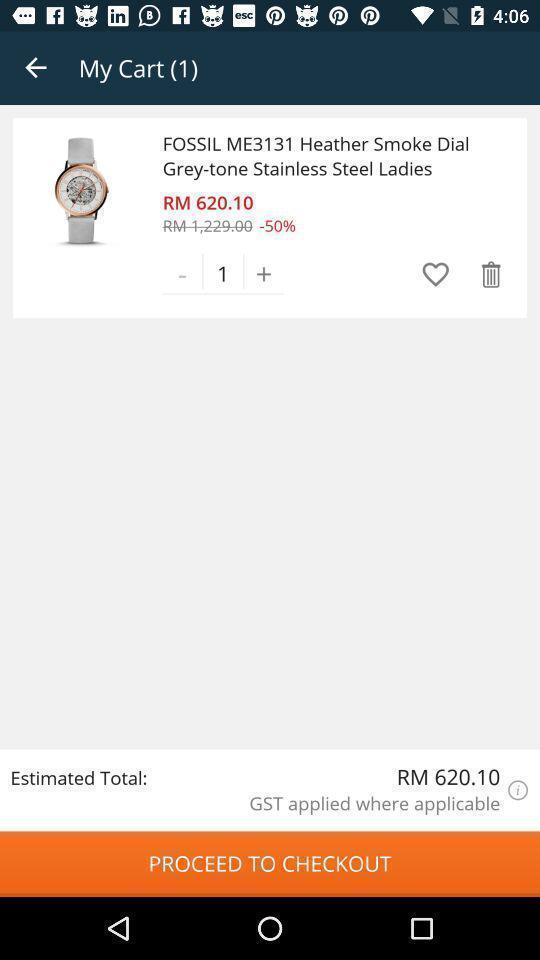What details can you identify in this image? Page showing your cart list in the shopping app. 